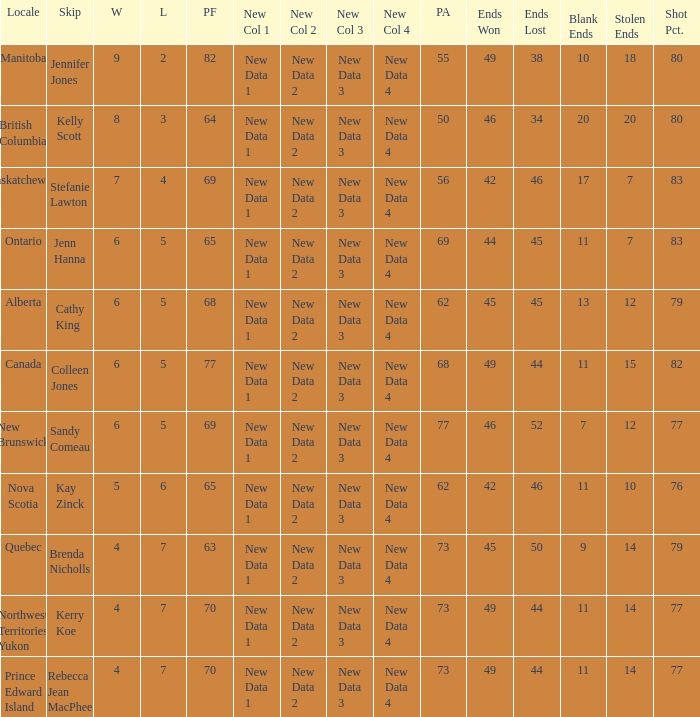What is the PA when the skip is Colleen Jones? 68.0. 